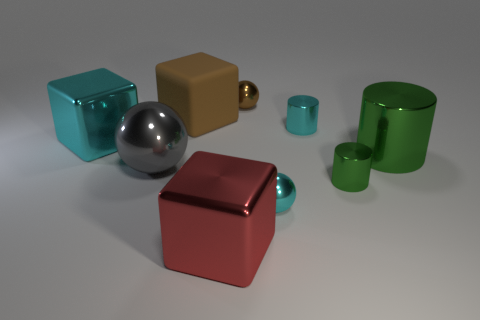Subtract all tiny metal spheres. How many spheres are left? 1 Add 1 large shiny blocks. How many objects exist? 10 Subtract all spheres. How many objects are left? 6 Subtract all small blue spheres. Subtract all small brown things. How many objects are left? 8 Add 9 red objects. How many red objects are left? 10 Add 1 big gray shiny objects. How many big gray shiny objects exist? 2 Subtract 0 green blocks. How many objects are left? 9 